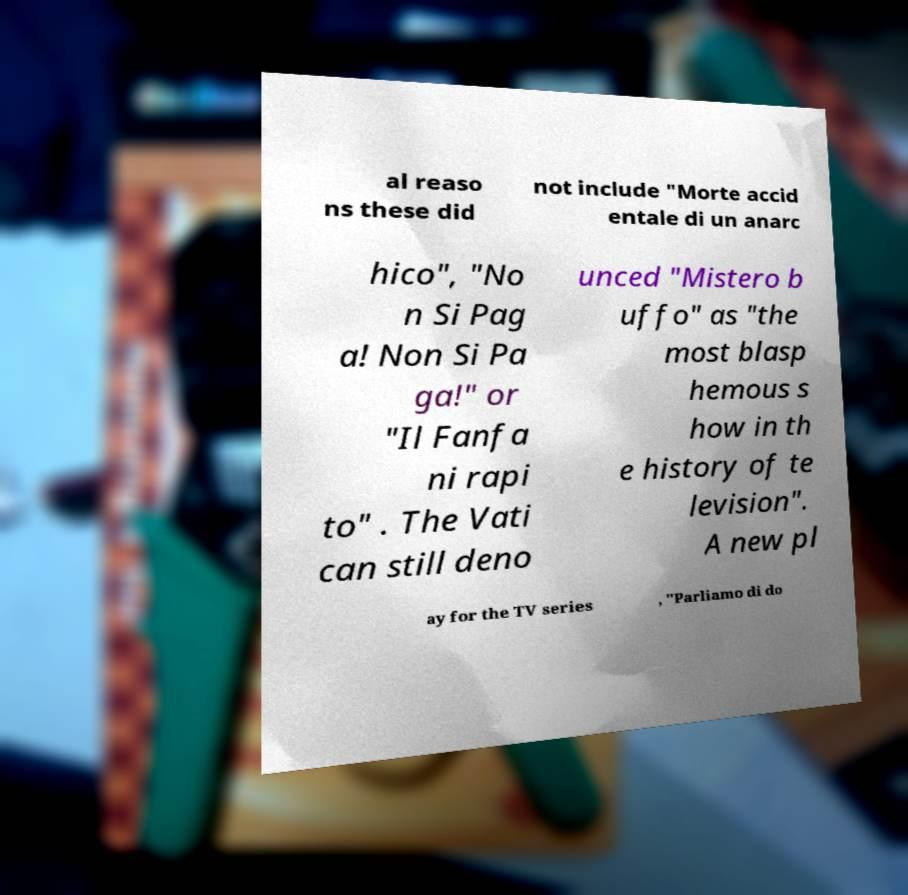Could you assist in decoding the text presented in this image and type it out clearly? al reaso ns these did not include "Morte accid entale di un anarc hico", "No n Si Pag a! Non Si Pa ga!" or "Il Fanfa ni rapi to" . The Vati can still deno unced "Mistero b uffo" as "the most blasp hemous s how in th e history of te levision". A new pl ay for the TV series , "Parliamo di do 